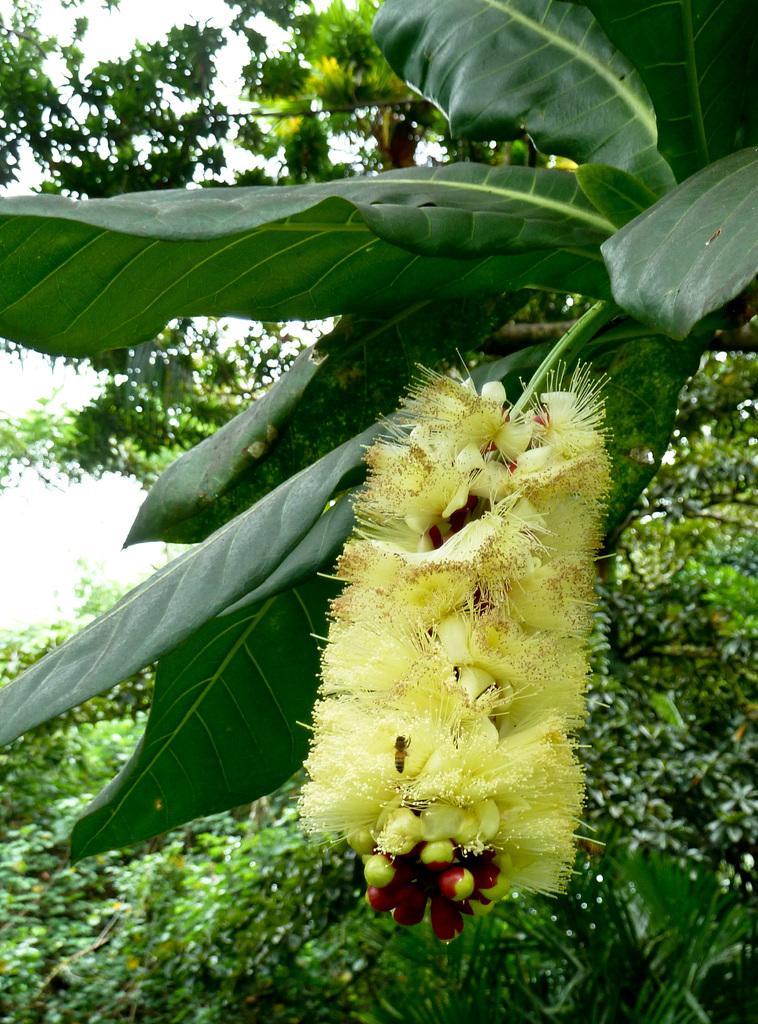How would you summarize this image in a sentence or two? In this picture I can see a tree with a flower, there is an insect on the flower, there are trees, and in the background there is sky. 